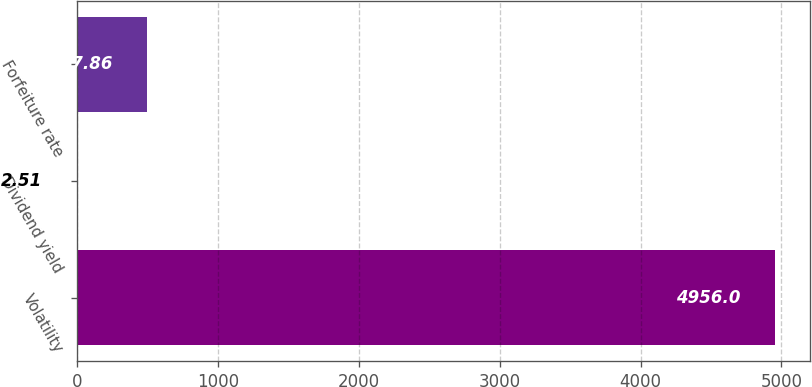<chart> <loc_0><loc_0><loc_500><loc_500><bar_chart><fcel>Volatility<fcel>Dividend yield<fcel>Forfeiture rate<nl><fcel>4956<fcel>2.51<fcel>497.86<nl></chart> 